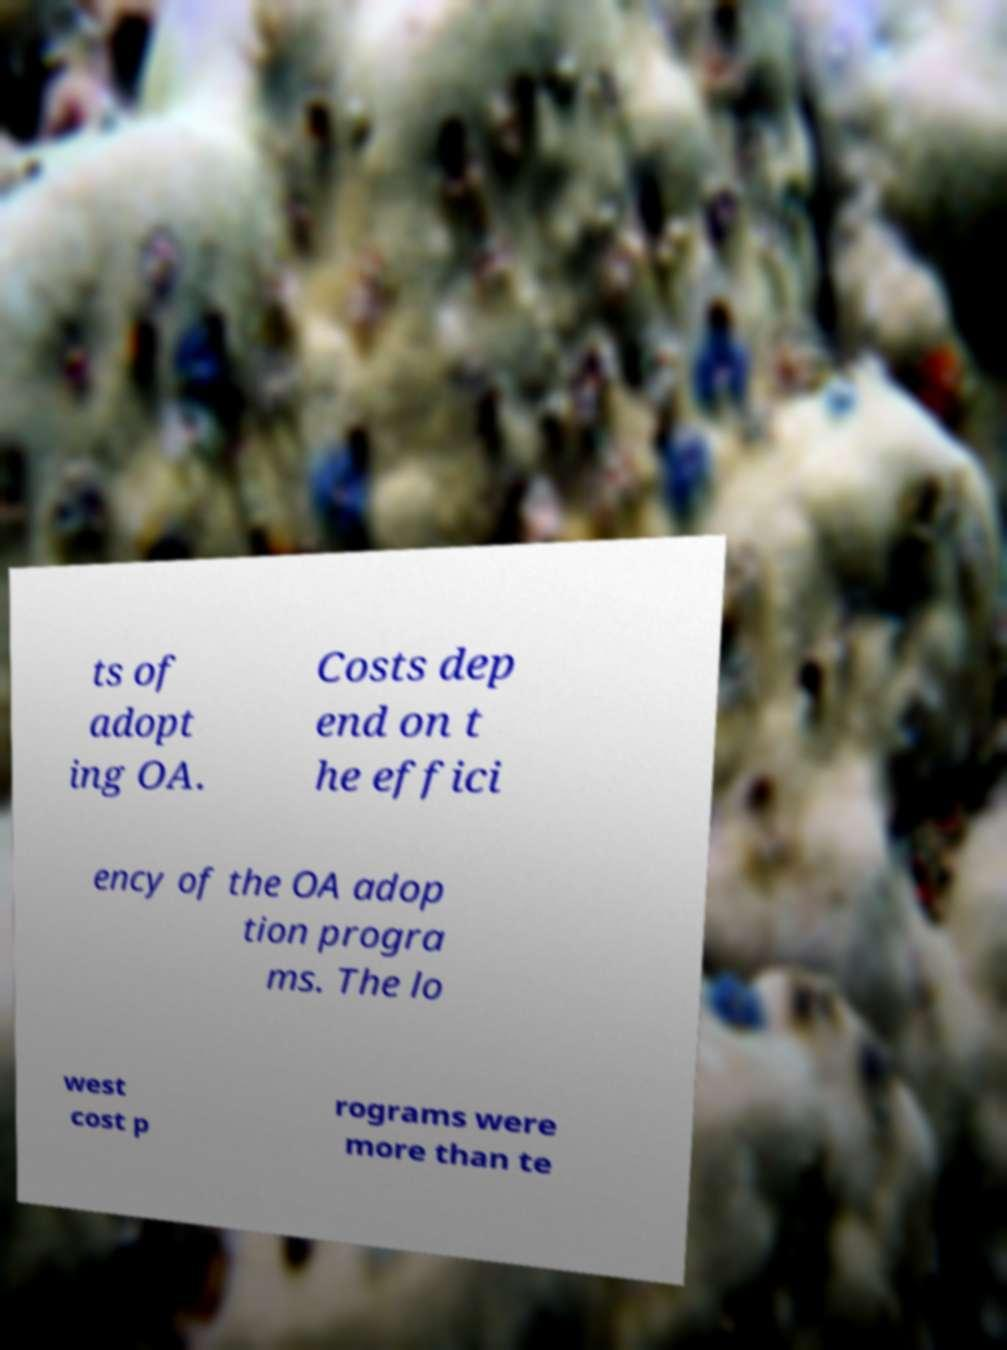For documentation purposes, I need the text within this image transcribed. Could you provide that? ts of adopt ing OA. Costs dep end on t he effici ency of the OA adop tion progra ms. The lo west cost p rograms were more than te 